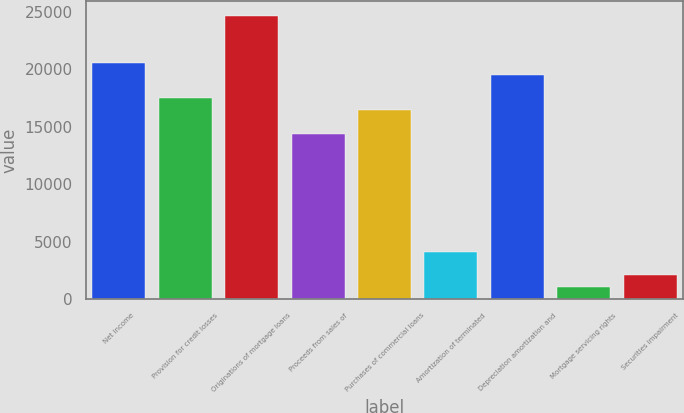Convert chart. <chart><loc_0><loc_0><loc_500><loc_500><bar_chart><fcel>Net income<fcel>Provision for credit losses<fcel>Originations of mortgage loans<fcel>Proceeds from sales of<fcel>Purchases of commercial loans<fcel>Amortization of terminated<fcel>Depreciation amortization and<fcel>Mortgage servicing rights<fcel>Securities impairment<nl><fcel>20545<fcel>17463.7<fcel>24653.4<fcel>14382.4<fcel>16436.6<fcel>4111.4<fcel>19517.9<fcel>1030.1<fcel>2057.2<nl></chart> 